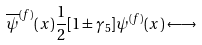Convert formula to latex. <formula><loc_0><loc_0><loc_500><loc_500>\overline { \psi } ^ { ( f ) } ( x ) \frac { 1 } { 2 } [ 1 \pm \gamma _ { 5 } ] \psi ^ { ( f ) } ( x ) \longleftrightarrow</formula> 